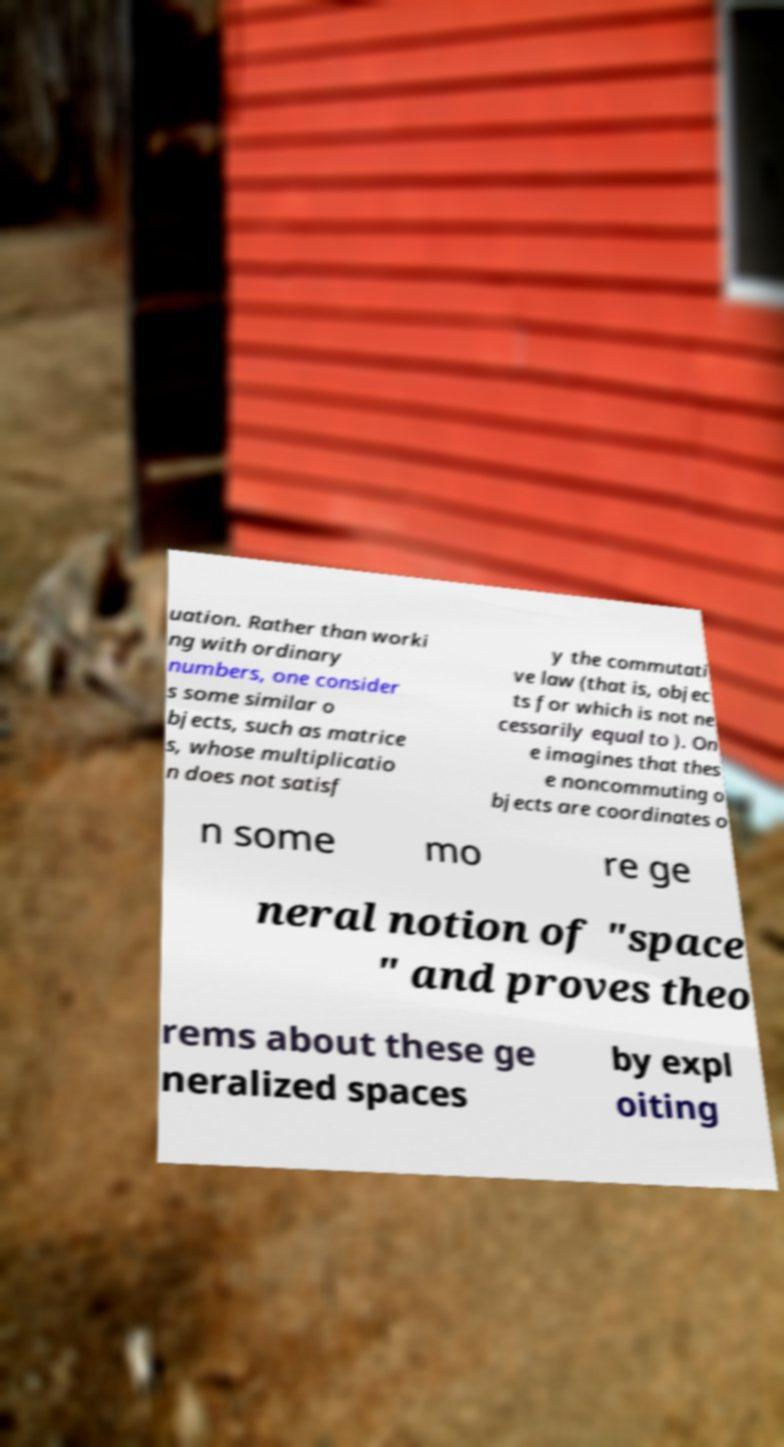Please identify and transcribe the text found in this image. uation. Rather than worki ng with ordinary numbers, one consider s some similar o bjects, such as matrice s, whose multiplicatio n does not satisf y the commutati ve law (that is, objec ts for which is not ne cessarily equal to ). On e imagines that thes e noncommuting o bjects are coordinates o n some mo re ge neral notion of "space " and proves theo rems about these ge neralized spaces by expl oiting 